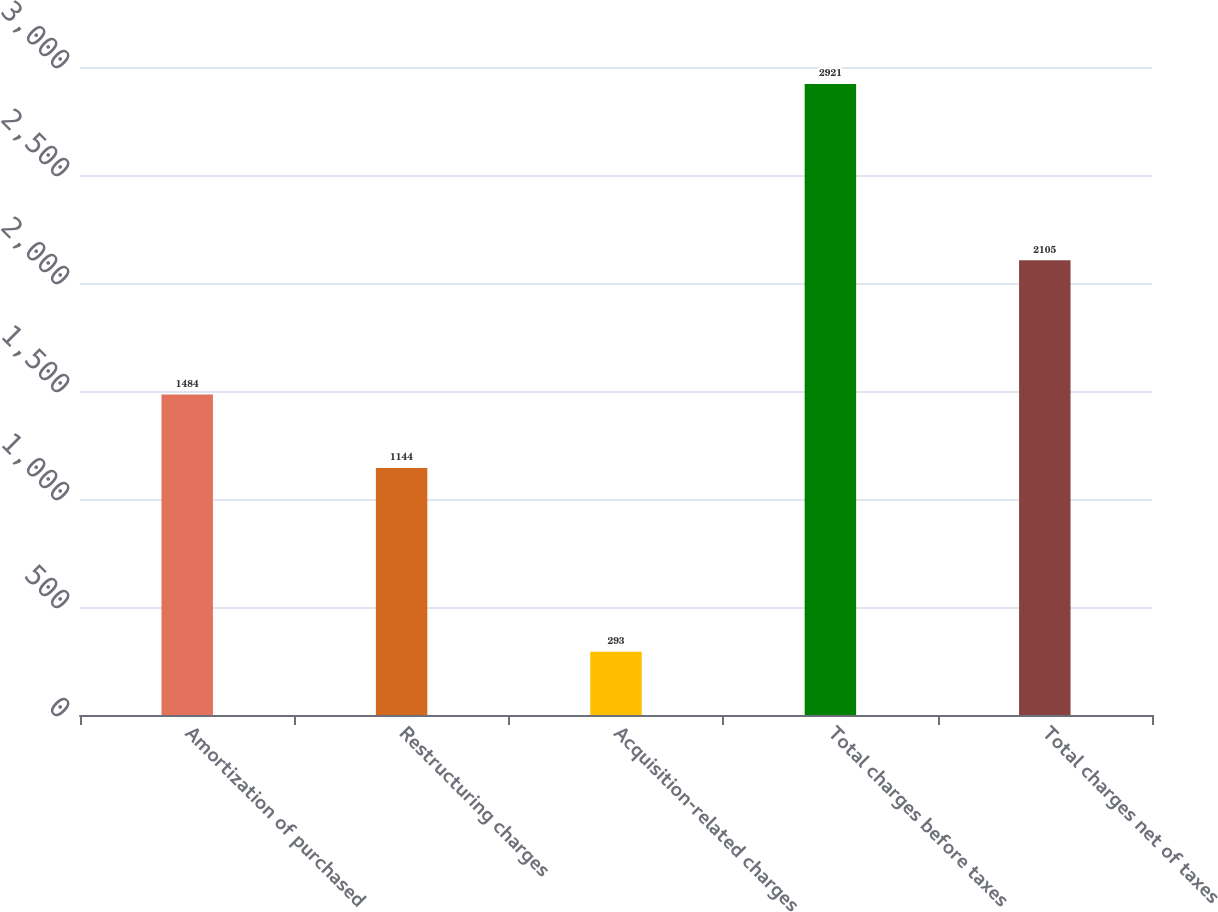<chart> <loc_0><loc_0><loc_500><loc_500><bar_chart><fcel>Amortization of purchased<fcel>Restructuring charges<fcel>Acquisition-related charges<fcel>Total charges before taxes<fcel>Total charges net of taxes<nl><fcel>1484<fcel>1144<fcel>293<fcel>2921<fcel>2105<nl></chart> 